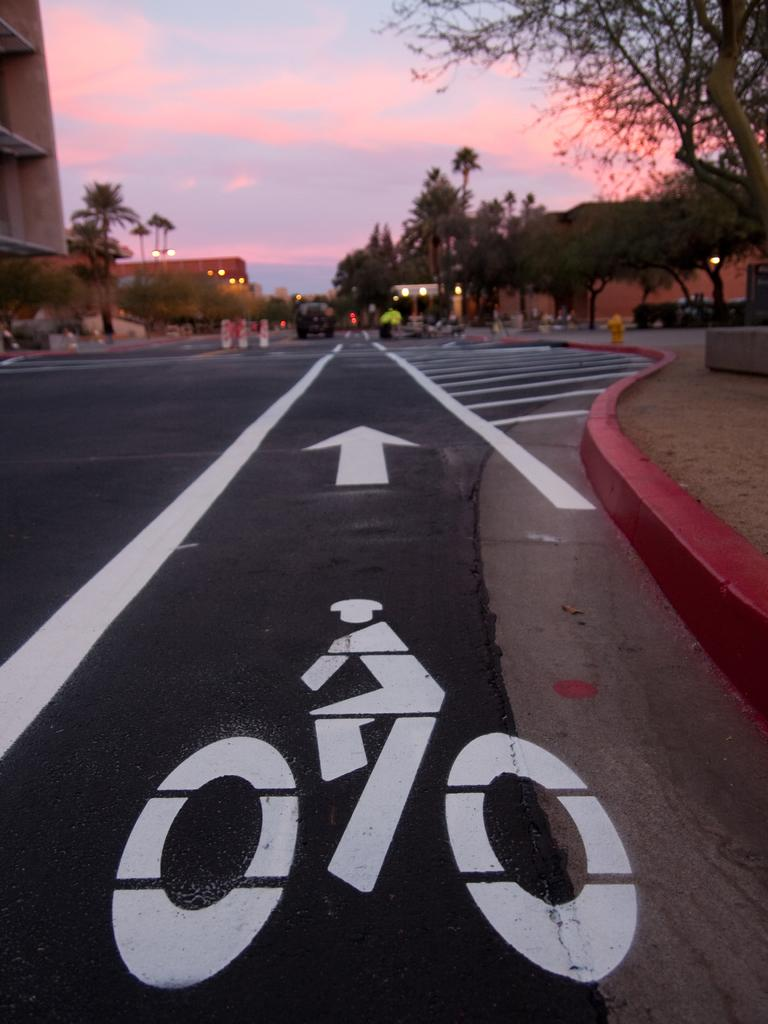What is on the road in the image? There is a vehicle on the road in the image. What type of natural elements can be seen in the image? Trees are visible in the image. What type of artificial elements can be seen in the image? Lights and buildings are visible in the image. What is visible in the background of the image? The sky is visible in the background of the image. What type of pain is the vehicle experiencing in the image? Vehicles do not experience pain, so this question is not applicable to the image. 